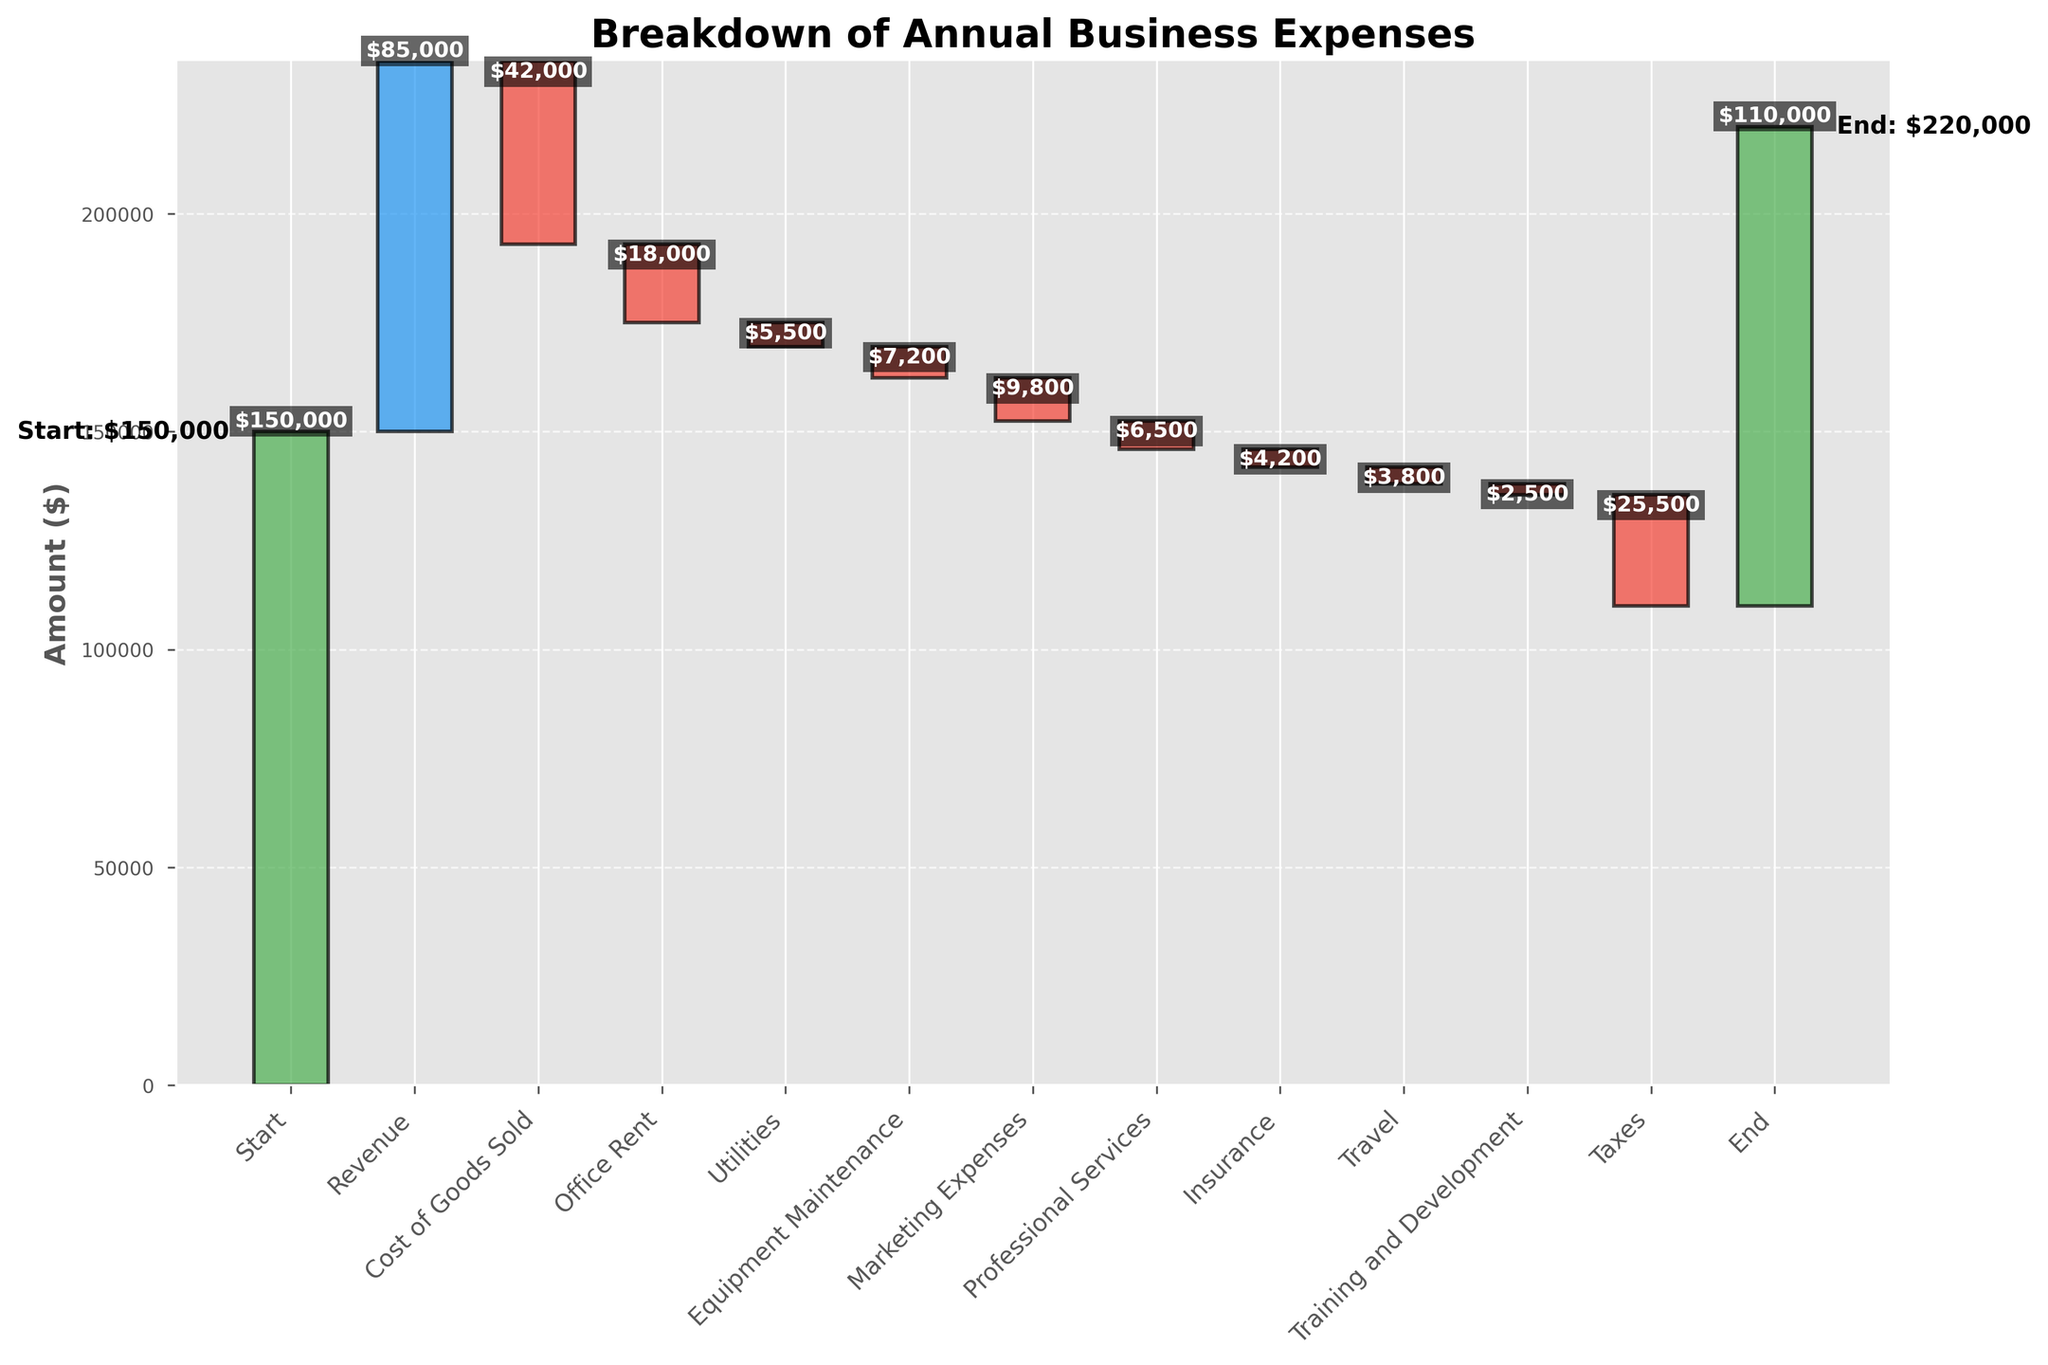What is the title of the chart? The title of the chart is typically found at the top of the figure. In this case, the title is "Breakdown of Annual Business Expenses" based on the code provided.
Answer: Breakdown of Annual Business Expenses How many categories are displayed on the x-axis? By counting the category labels on the x-axis, we find that there are 13 categories, starting from 'Start' and ending with 'End'.
Answer: 13 What is the total revenue amount? The revenue amount can be directly observed from the 'Revenue' category bar in the chart, which is shown to be $85,000.
Answer: 85,000 How much is the cost of goods sold? The 'Cost of Goods Sold' category shows a negative value, which can be seen as -$42,000 directly from the figure.
Answer: 42,000 Which expense category has the highest amount? To determine the highest amount, compare the magnitude of the negative bars representing expenses. 'Taxes' has the highest value at -$25,500.
Answer: Taxes What is the net change after office rent and utilities? The figure shows -$18,000 for office rent and -$5,500 for utilities. The net change is the sum of these values: -$18,000 + -$5,500 = -$23,500.
Answer: -23,500 What is the final amount after all expenses? The final (cumulative) value presented at the 'End' category can be directly seen, which is $110,000.
Answer: 110,000 What is the difference between the start and end amounts? The start amount is $150,000, and the end amount is $110,000. The difference between these two values is $150,000 - $110,000 = $40,000.
Answer: 40,000 How does professional services expense compare to marketing expenses? The chart shows professional services at -$6,500 and marketing expenses at -$9,800. Comparing these, marketing expenses are higher than professional services by $9,800 - $6,500 = $3,300.
Answer: Marketing expenses are $3,300 higher Which expense has the smallest impact on the profits? The smallest impact is determined by comparing the absolute values of the negative bars. 'Training and Development' has the smallest value at -$2,500.
Answer: Training and Development 